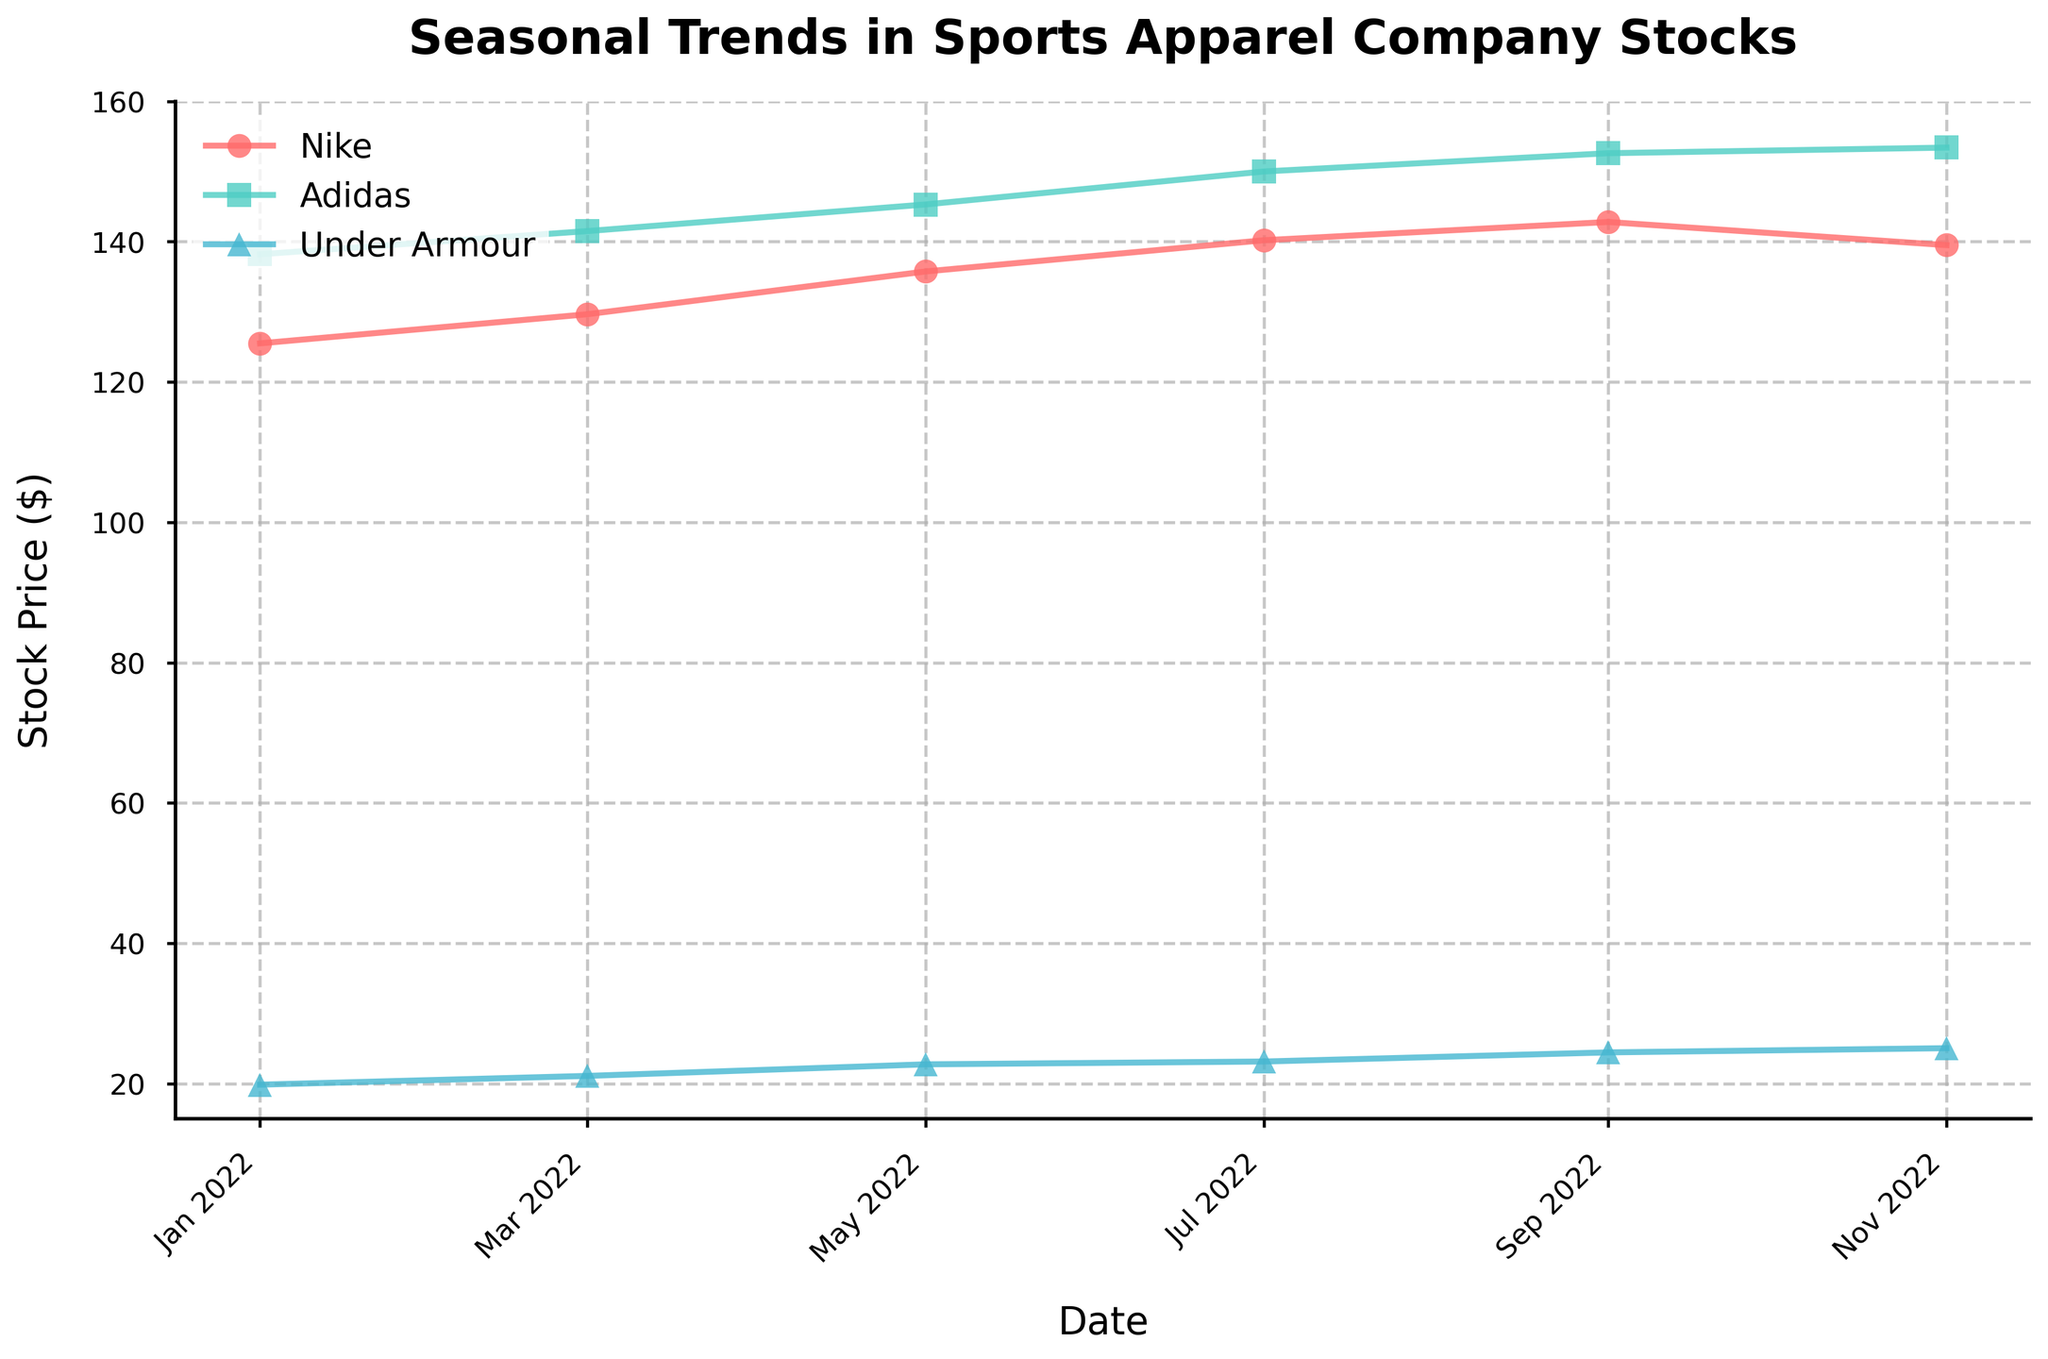What is the title of the plot? The title is prominently displayed at the top of the plot in bold and large font.
Answer: Seasonal Trends in Sports Apparel Company Stocks How many companies are represented in the plot? There are three unique lines, each with a different color and marker style, representing three companies.
Answer: Three Which company had the highest stock price in November 2022? Look at the data points for November 2022 and identify which line is the highest on the y-axis.
Answer: Adidas Between May 2022 and July 2022, which company showed the biggest increase in stock price? Calculate the difference in stock prices for Nike, Adidas, and Under Armour between May and July. The company with the largest positive difference is the answer.
Answer: Under Armour How does the stock price trend for Adidas compare to Nike throughout the year? By visually inspecting the plot, compare the upward or downward trends of the lines representing Adidas and Nike month by month.
Answer: Adidas consistently trends upward, while Nike has a slight dip in November What was Nike's stock price in January 2022 versus November 2022? Locate Nike’s line and check its starting (January) and ending (November) points on the y-axis.
Answer: $125.50 in January and $139.50 in November Which company showed the most steady increase in stock price throughout 2022? Look at the trend lines for steady upward movement without significant dips or fluctuations.
Answer: Adidas From March 2022 to September 2022, which company had a greater average stock price? Calculate the average stock price in the given months for each company and compare these averages.
Answer: Adidas By how much did Under Armour's stock price increase from January 2022 to November 2022? Subtract the stock price in January from the stock price in November for Under Armour.
Answer: $5.20 Do all three companies show an upward trend in stock prices from January to November 2022? Examine the general direction of each company’s line from start (January) to end (November).
Answer: Yes 